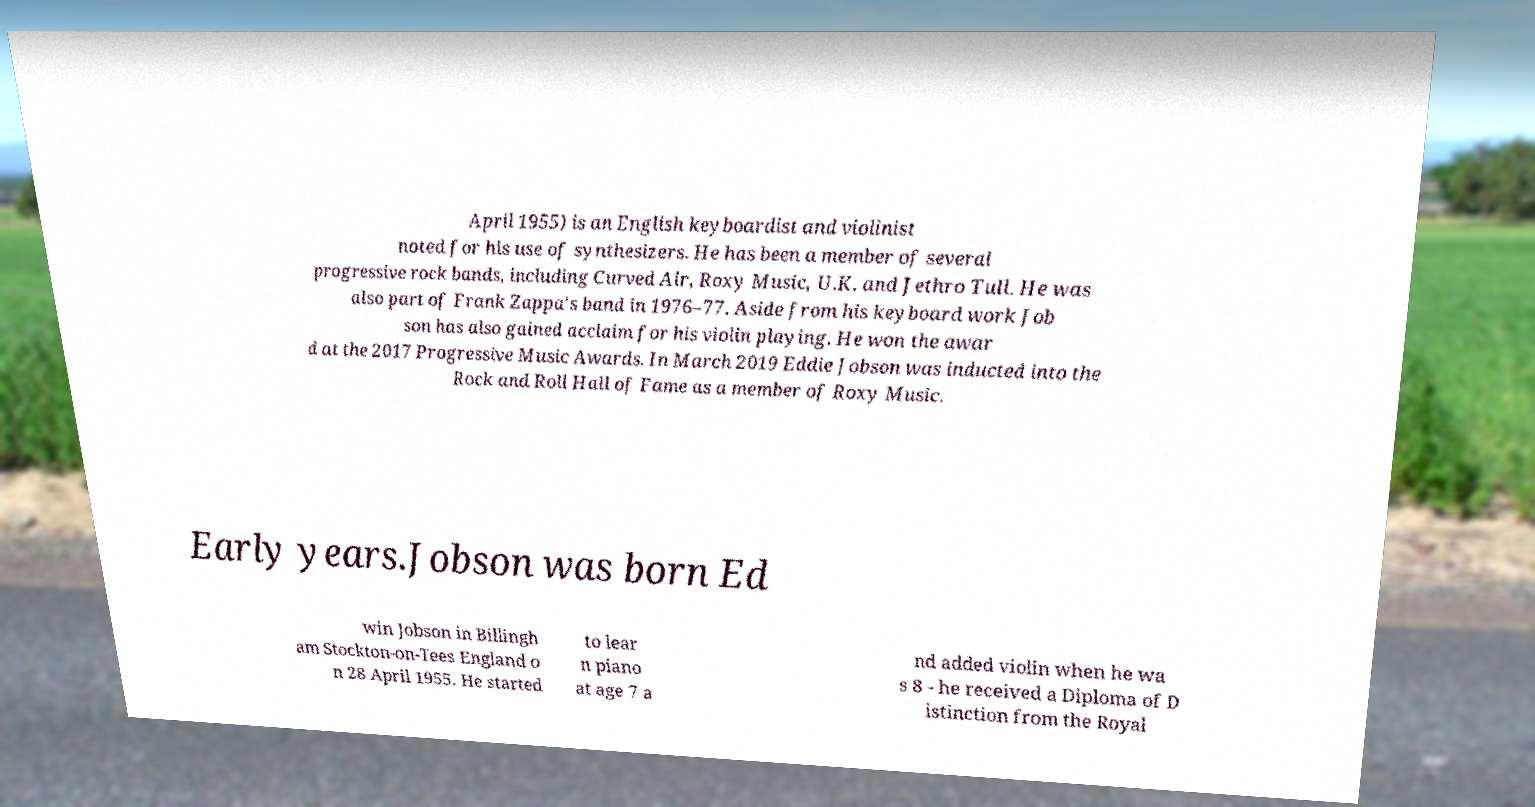I need the written content from this picture converted into text. Can you do that? April 1955) is an English keyboardist and violinist noted for his use of synthesizers. He has been a member of several progressive rock bands, including Curved Air, Roxy Music, U.K. and Jethro Tull. He was also part of Frank Zappa's band in 1976–77. Aside from his keyboard work Job son has also gained acclaim for his violin playing. He won the awar d at the 2017 Progressive Music Awards. In March 2019 Eddie Jobson was inducted into the Rock and Roll Hall of Fame as a member of Roxy Music. Early years.Jobson was born Ed win Jobson in Billingh am Stockton-on-Tees England o n 28 April 1955. He started to lear n piano at age 7 a nd added violin when he wa s 8 - he received a Diploma of D istinction from the Royal 